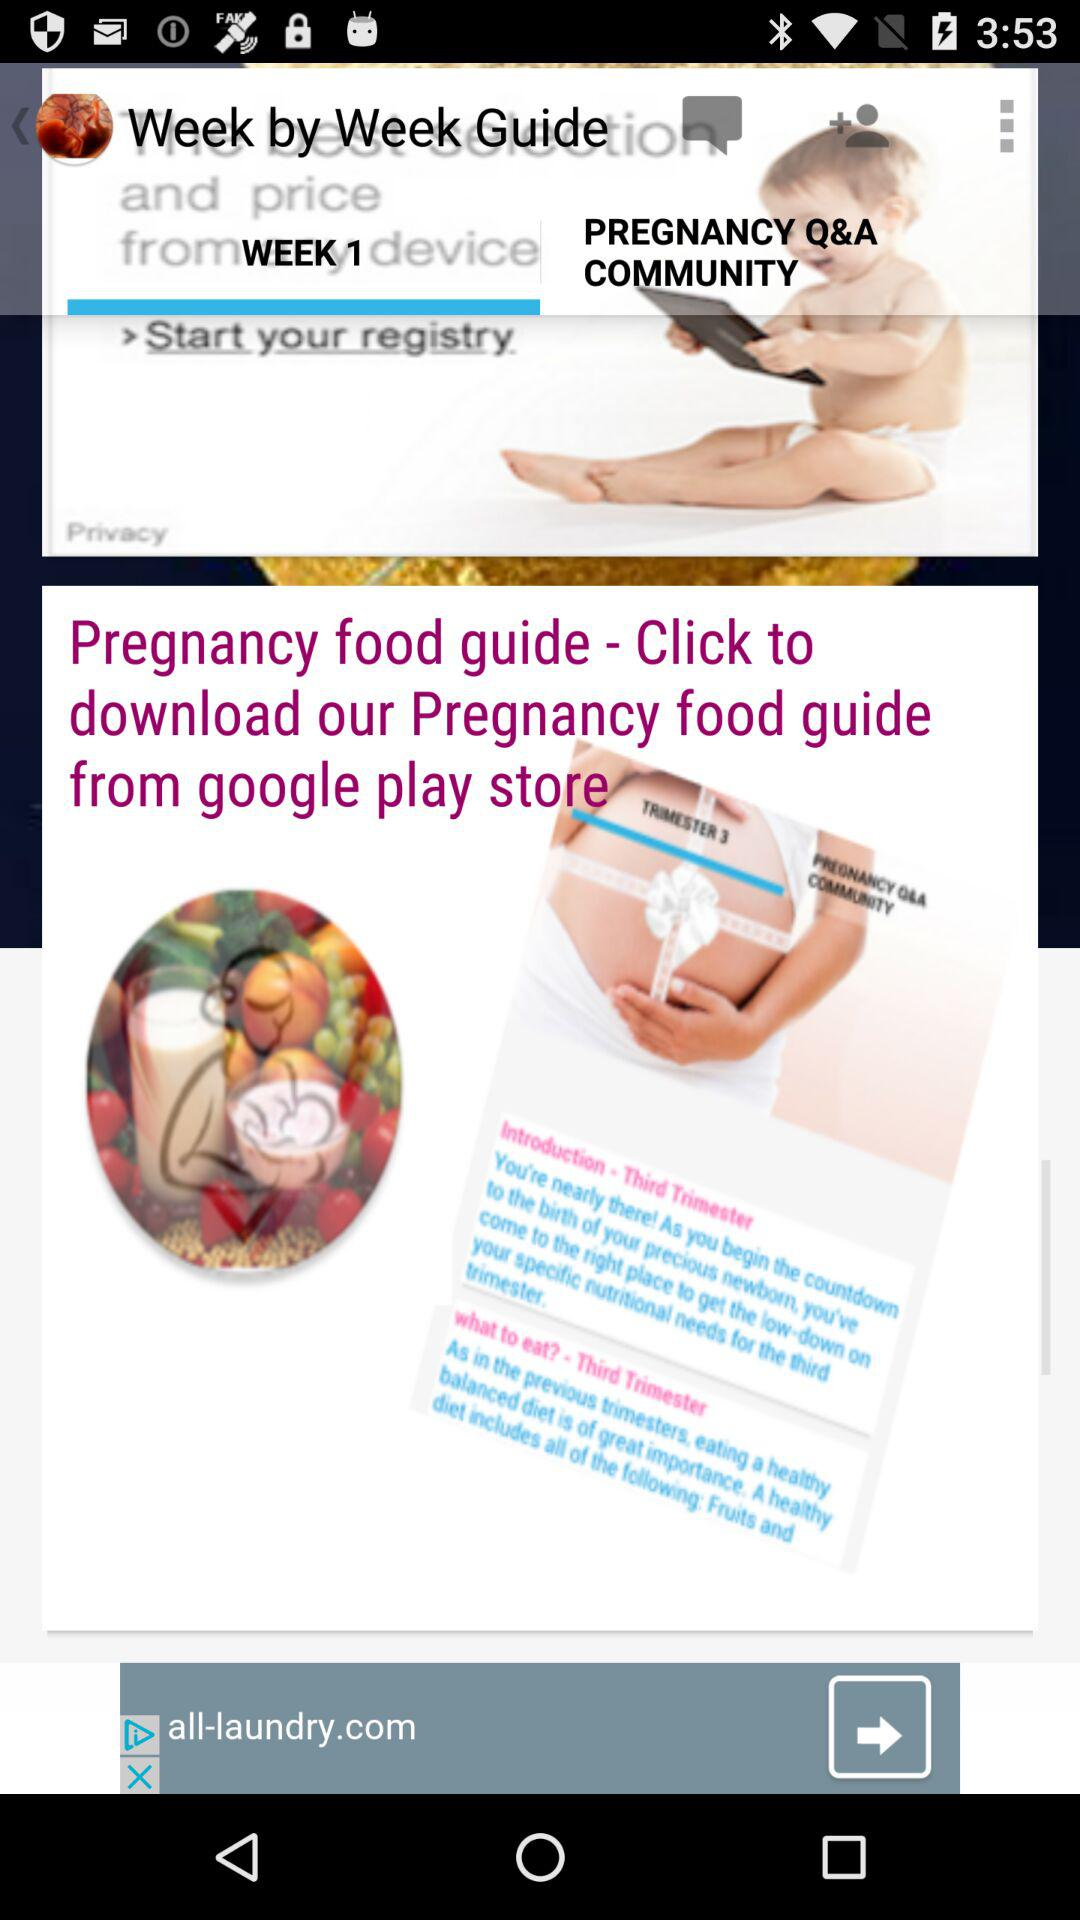Which tab is selected? The selected tab is "WEEK 1". 